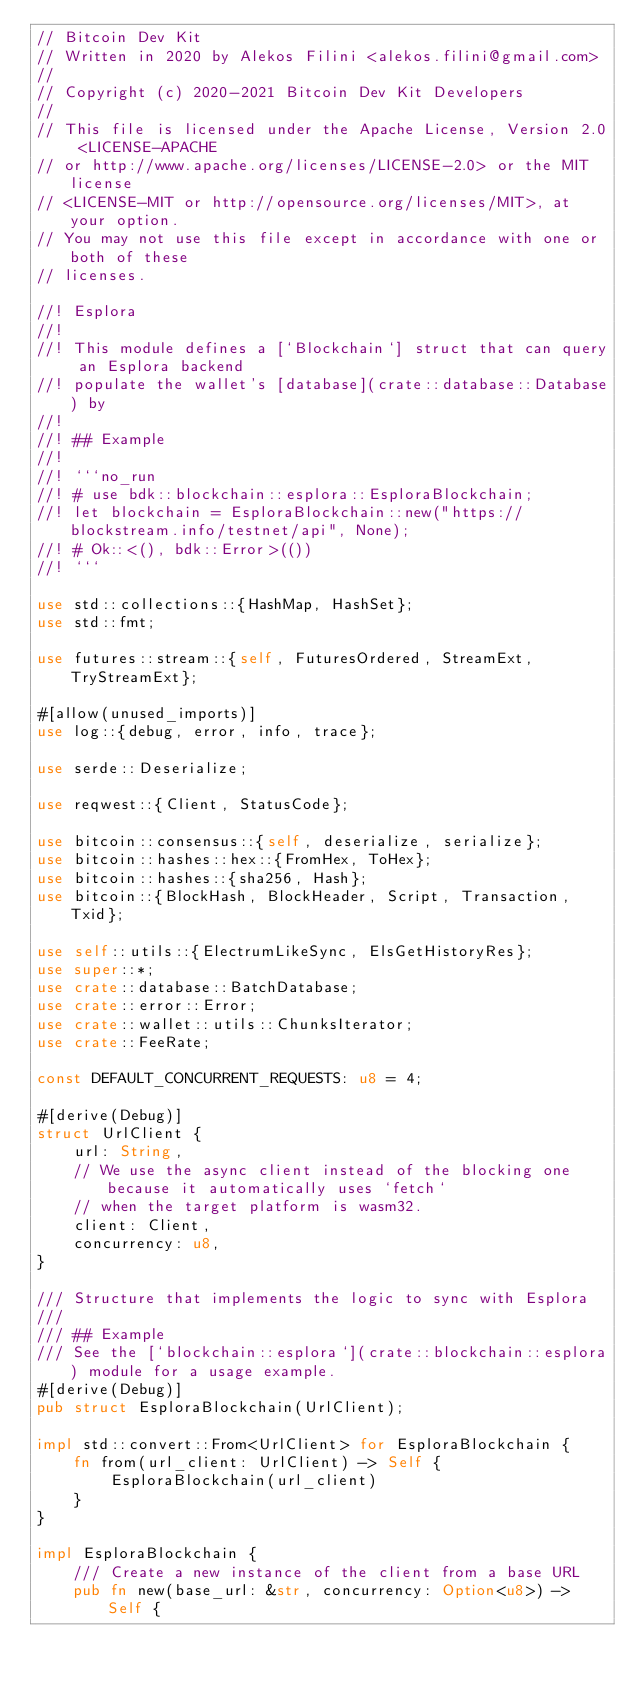Convert code to text. <code><loc_0><loc_0><loc_500><loc_500><_Rust_>// Bitcoin Dev Kit
// Written in 2020 by Alekos Filini <alekos.filini@gmail.com>
//
// Copyright (c) 2020-2021 Bitcoin Dev Kit Developers
//
// This file is licensed under the Apache License, Version 2.0 <LICENSE-APACHE
// or http://www.apache.org/licenses/LICENSE-2.0> or the MIT license
// <LICENSE-MIT or http://opensource.org/licenses/MIT>, at your option.
// You may not use this file except in accordance with one or both of these
// licenses.

//! Esplora
//!
//! This module defines a [`Blockchain`] struct that can query an Esplora backend
//! populate the wallet's [database](crate::database::Database) by
//!
//! ## Example
//!
//! ```no_run
//! # use bdk::blockchain::esplora::EsploraBlockchain;
//! let blockchain = EsploraBlockchain::new("https://blockstream.info/testnet/api", None);
//! # Ok::<(), bdk::Error>(())
//! ```

use std::collections::{HashMap, HashSet};
use std::fmt;

use futures::stream::{self, FuturesOrdered, StreamExt, TryStreamExt};

#[allow(unused_imports)]
use log::{debug, error, info, trace};

use serde::Deserialize;

use reqwest::{Client, StatusCode};

use bitcoin::consensus::{self, deserialize, serialize};
use bitcoin::hashes::hex::{FromHex, ToHex};
use bitcoin::hashes::{sha256, Hash};
use bitcoin::{BlockHash, BlockHeader, Script, Transaction, Txid};

use self::utils::{ElectrumLikeSync, ElsGetHistoryRes};
use super::*;
use crate::database::BatchDatabase;
use crate::error::Error;
use crate::wallet::utils::ChunksIterator;
use crate::FeeRate;

const DEFAULT_CONCURRENT_REQUESTS: u8 = 4;

#[derive(Debug)]
struct UrlClient {
    url: String,
    // We use the async client instead of the blocking one because it automatically uses `fetch`
    // when the target platform is wasm32.
    client: Client,
    concurrency: u8,
}

/// Structure that implements the logic to sync with Esplora
///
/// ## Example
/// See the [`blockchain::esplora`](crate::blockchain::esplora) module for a usage example.
#[derive(Debug)]
pub struct EsploraBlockchain(UrlClient);

impl std::convert::From<UrlClient> for EsploraBlockchain {
    fn from(url_client: UrlClient) -> Self {
        EsploraBlockchain(url_client)
    }
}

impl EsploraBlockchain {
    /// Create a new instance of the client from a base URL
    pub fn new(base_url: &str, concurrency: Option<u8>) -> Self {</code> 